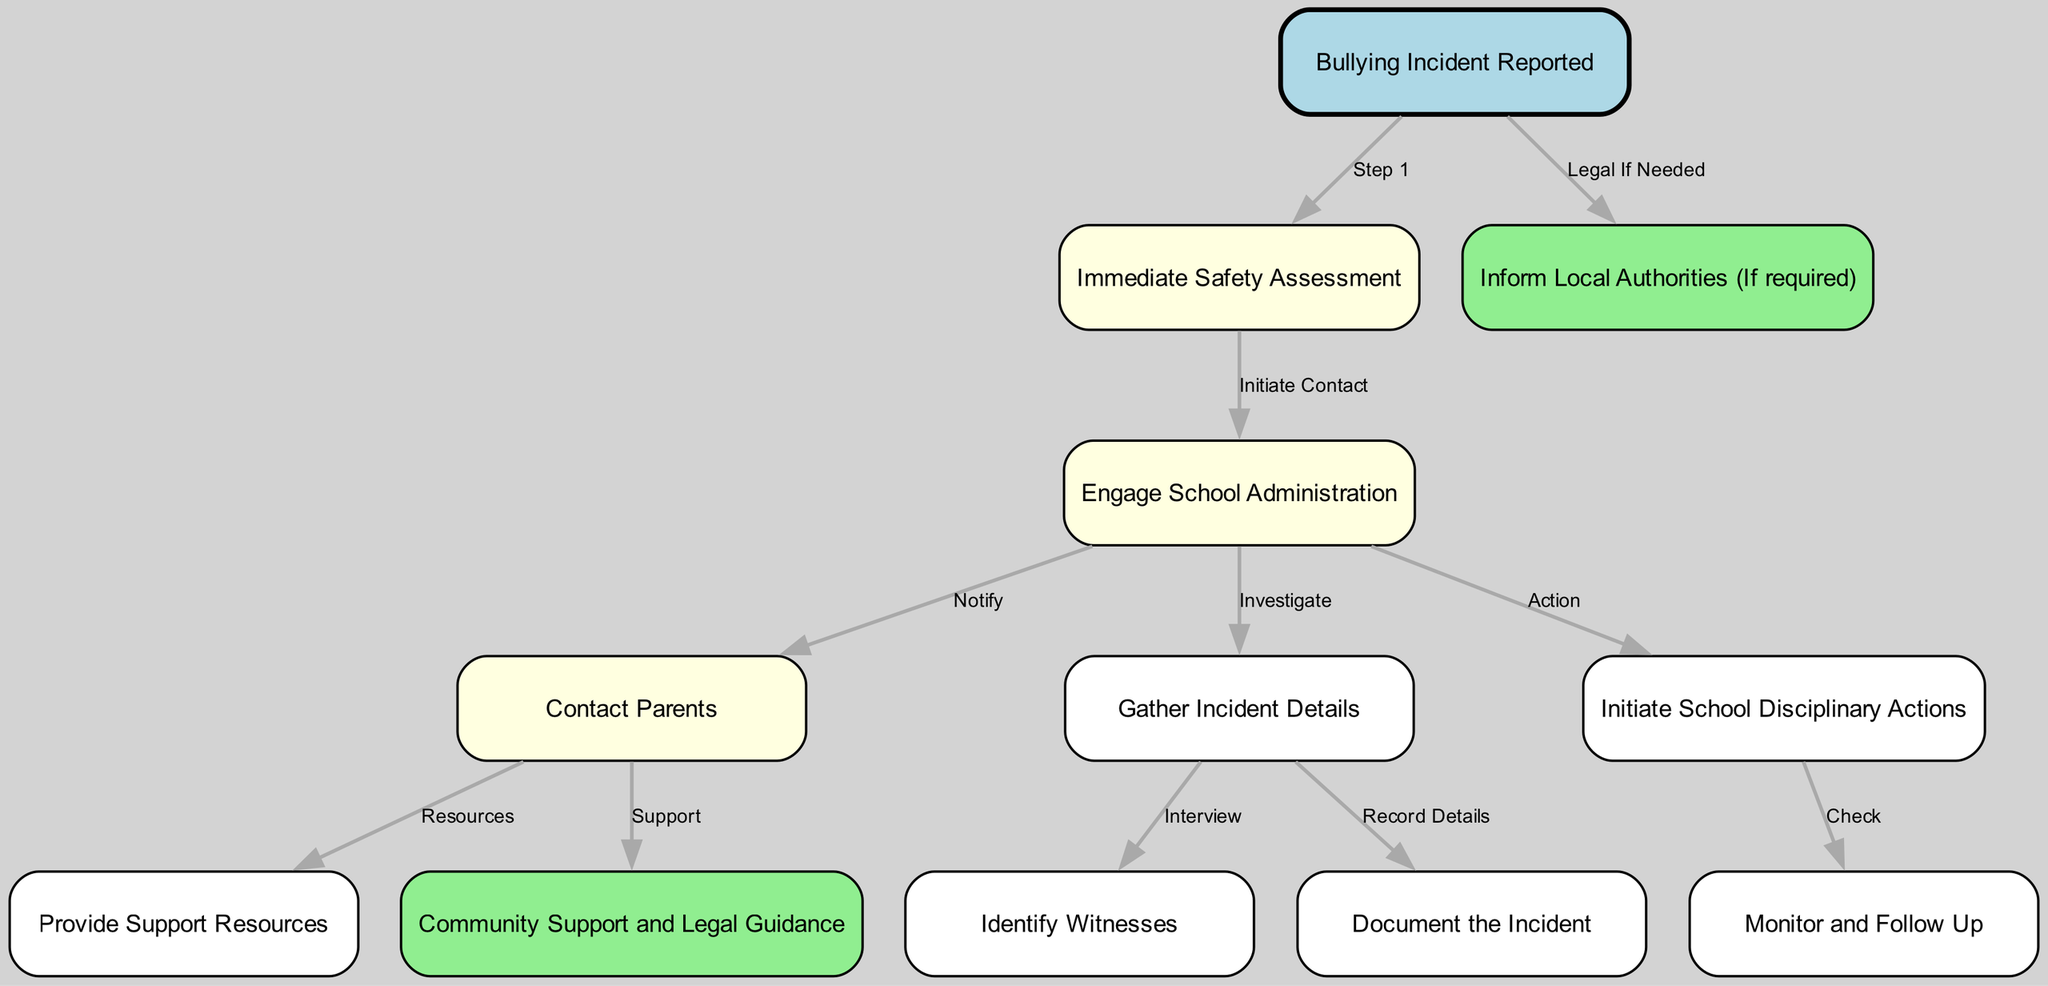What is the first step in the workflow? The first node in the diagram represents the beginning of the workflow, labeled "Bullying Incident Reported." Hence, this is the initial step that initiates the process.
Answer: Bullying Incident Reported How many nodes are in the diagram? By counting all the individual nodes listed in the diagram, there are a total of twelve nodes that represent various stages in the workflow.
Answer: 12 What color represents the 'Engage School Administration' node? The node representing 'Engage School Administration' is colored light yellow, as provided in the styling of the diagram's nodes.
Answer: Light yellow Which node comes after 'Immediate Safety Assessment'? The next node in the workflow following 'Immediate Safety Assessment' is 'Engage School Administration,' as indicated by the directed edge connecting them.
Answer: Engage School Administration What action follows after 'Document the Incident'? The edge from 'Document the Incident' leads to 'Monitor and Follow Up,' meaning that 'Monitor and Follow Up' is the action that occurs next in the process.
Answer: Monitor and Follow Up What resources are provided after contacting parents? After 'Contact Parents,' the resources provided are represented by the node labeled 'Provide Support Resources,' which indicates that support options are shared with the family.
Answer: Provide Support Resources If a bullying incident is reported, who may be informed if needed? If there is a need for further action based on the incident, the node 'Inform Local Authorities (If required)' signifies that local authorities may be contacted in this case.
Answer: Inform Local Authorities (If required) How many disciplinary actions are initiated after the Engage School Administration step? Following the 'Engage School Administration' step, there is one node that details the initiation of school disciplinary actions and connects to another step for monitoring.
Answer: One What is the common outcome of steps that involve 'Gather Incident Details'? Steps involving 'Gather Incident Details' lead to both identifying witnesses and documenting the incident. This indicates that both processes are crucial for a thorough investigation.
Answer: Identify witnesses and Document the incident 